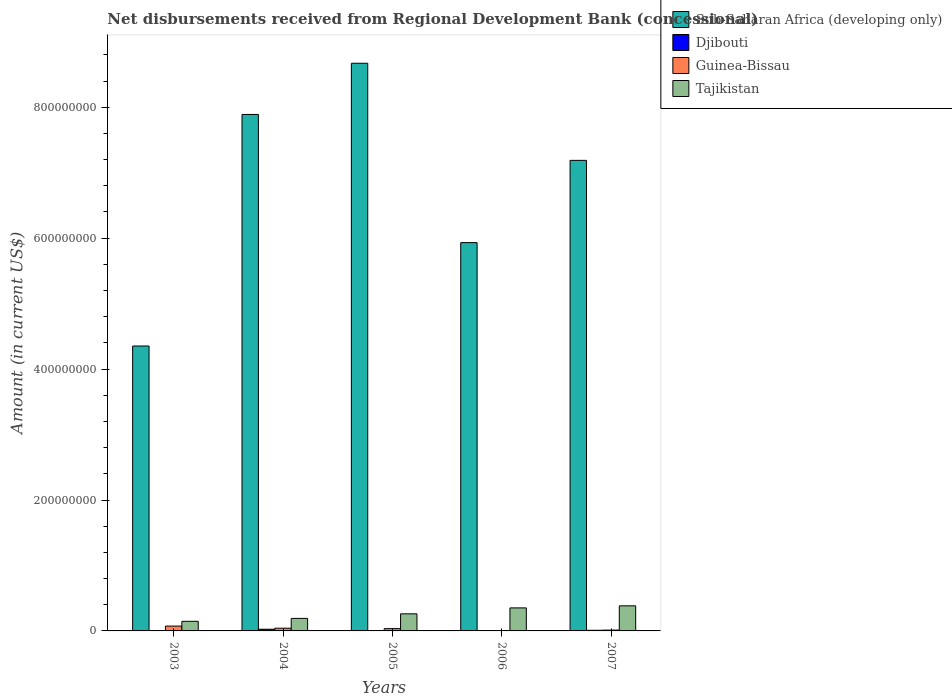How many different coloured bars are there?
Give a very brief answer. 4. Are the number of bars on each tick of the X-axis equal?
Offer a very short reply. No. How many bars are there on the 2nd tick from the left?
Provide a succinct answer. 4. How many bars are there on the 2nd tick from the right?
Ensure brevity in your answer.  4. What is the label of the 2nd group of bars from the left?
Provide a succinct answer. 2004. In how many cases, is the number of bars for a given year not equal to the number of legend labels?
Make the answer very short. 1. What is the amount of disbursements received from Regional Development Bank in Sub-Saharan Africa (developing only) in 2003?
Your answer should be compact. 4.35e+08. Across all years, what is the maximum amount of disbursements received from Regional Development Bank in Djibouti?
Your response must be concise. 2.58e+06. Across all years, what is the minimum amount of disbursements received from Regional Development Bank in Sub-Saharan Africa (developing only)?
Keep it short and to the point. 4.35e+08. In which year was the amount of disbursements received from Regional Development Bank in Guinea-Bissau maximum?
Ensure brevity in your answer.  2003. What is the total amount of disbursements received from Regional Development Bank in Sub-Saharan Africa (developing only) in the graph?
Ensure brevity in your answer.  3.40e+09. What is the difference between the amount of disbursements received from Regional Development Bank in Tajikistan in 2003 and that in 2006?
Make the answer very short. -2.05e+07. What is the difference between the amount of disbursements received from Regional Development Bank in Tajikistan in 2003 and the amount of disbursements received from Regional Development Bank in Djibouti in 2005?
Provide a succinct answer. 1.41e+07. What is the average amount of disbursements received from Regional Development Bank in Sub-Saharan Africa (developing only) per year?
Your answer should be compact. 6.81e+08. In the year 2005, what is the difference between the amount of disbursements received from Regional Development Bank in Tajikistan and amount of disbursements received from Regional Development Bank in Guinea-Bissau?
Provide a succinct answer. 2.26e+07. In how many years, is the amount of disbursements received from Regional Development Bank in Sub-Saharan Africa (developing only) greater than 600000000 US$?
Keep it short and to the point. 3. What is the ratio of the amount of disbursements received from Regional Development Bank in Tajikistan in 2003 to that in 2004?
Your response must be concise. 0.77. Is the difference between the amount of disbursements received from Regional Development Bank in Tajikistan in 2003 and 2004 greater than the difference between the amount of disbursements received from Regional Development Bank in Guinea-Bissau in 2003 and 2004?
Give a very brief answer. No. What is the difference between the highest and the second highest amount of disbursements received from Regional Development Bank in Sub-Saharan Africa (developing only)?
Give a very brief answer. 7.82e+07. What is the difference between the highest and the lowest amount of disbursements received from Regional Development Bank in Guinea-Bissau?
Your answer should be compact. 6.83e+06. In how many years, is the amount of disbursements received from Regional Development Bank in Sub-Saharan Africa (developing only) greater than the average amount of disbursements received from Regional Development Bank in Sub-Saharan Africa (developing only) taken over all years?
Ensure brevity in your answer.  3. Is it the case that in every year, the sum of the amount of disbursements received from Regional Development Bank in Tajikistan and amount of disbursements received from Regional Development Bank in Djibouti is greater than the amount of disbursements received from Regional Development Bank in Guinea-Bissau?
Offer a very short reply. Yes. Are all the bars in the graph horizontal?
Provide a succinct answer. No. What is the difference between two consecutive major ticks on the Y-axis?
Provide a short and direct response. 2.00e+08. Are the values on the major ticks of Y-axis written in scientific E-notation?
Provide a succinct answer. No. What is the title of the graph?
Provide a succinct answer. Net disbursements received from Regional Development Bank (concessional). Does "Latin America(developing only)" appear as one of the legend labels in the graph?
Make the answer very short. No. What is the label or title of the Y-axis?
Your response must be concise. Amount (in current US$). What is the Amount (in current US$) of Sub-Saharan Africa (developing only) in 2003?
Provide a succinct answer. 4.35e+08. What is the Amount (in current US$) in Guinea-Bissau in 2003?
Provide a succinct answer. 7.40e+06. What is the Amount (in current US$) of Tajikistan in 2003?
Make the answer very short. 1.47e+07. What is the Amount (in current US$) of Sub-Saharan Africa (developing only) in 2004?
Make the answer very short. 7.89e+08. What is the Amount (in current US$) of Djibouti in 2004?
Keep it short and to the point. 2.58e+06. What is the Amount (in current US$) of Guinea-Bissau in 2004?
Give a very brief answer. 4.14e+06. What is the Amount (in current US$) of Tajikistan in 2004?
Keep it short and to the point. 1.91e+07. What is the Amount (in current US$) in Sub-Saharan Africa (developing only) in 2005?
Your response must be concise. 8.67e+08. What is the Amount (in current US$) of Djibouti in 2005?
Keep it short and to the point. 5.57e+05. What is the Amount (in current US$) of Guinea-Bissau in 2005?
Your response must be concise. 3.49e+06. What is the Amount (in current US$) in Tajikistan in 2005?
Your answer should be very brief. 2.61e+07. What is the Amount (in current US$) of Sub-Saharan Africa (developing only) in 2006?
Ensure brevity in your answer.  5.93e+08. What is the Amount (in current US$) of Djibouti in 2006?
Provide a short and direct response. 3.02e+05. What is the Amount (in current US$) in Guinea-Bissau in 2006?
Your answer should be very brief. 5.69e+05. What is the Amount (in current US$) of Tajikistan in 2006?
Your answer should be very brief. 3.52e+07. What is the Amount (in current US$) in Sub-Saharan Africa (developing only) in 2007?
Your answer should be very brief. 7.19e+08. What is the Amount (in current US$) of Djibouti in 2007?
Give a very brief answer. 9.96e+05. What is the Amount (in current US$) of Guinea-Bissau in 2007?
Your answer should be compact. 1.22e+06. What is the Amount (in current US$) of Tajikistan in 2007?
Your answer should be compact. 3.83e+07. Across all years, what is the maximum Amount (in current US$) in Sub-Saharan Africa (developing only)?
Give a very brief answer. 8.67e+08. Across all years, what is the maximum Amount (in current US$) of Djibouti?
Your response must be concise. 2.58e+06. Across all years, what is the maximum Amount (in current US$) of Guinea-Bissau?
Your answer should be compact. 7.40e+06. Across all years, what is the maximum Amount (in current US$) in Tajikistan?
Your response must be concise. 3.83e+07. Across all years, what is the minimum Amount (in current US$) in Sub-Saharan Africa (developing only)?
Your answer should be compact. 4.35e+08. Across all years, what is the minimum Amount (in current US$) of Guinea-Bissau?
Keep it short and to the point. 5.69e+05. Across all years, what is the minimum Amount (in current US$) of Tajikistan?
Provide a succinct answer. 1.47e+07. What is the total Amount (in current US$) of Sub-Saharan Africa (developing only) in the graph?
Give a very brief answer. 3.40e+09. What is the total Amount (in current US$) in Djibouti in the graph?
Ensure brevity in your answer.  4.43e+06. What is the total Amount (in current US$) in Guinea-Bissau in the graph?
Offer a very short reply. 1.68e+07. What is the total Amount (in current US$) of Tajikistan in the graph?
Keep it short and to the point. 1.33e+08. What is the difference between the Amount (in current US$) in Sub-Saharan Africa (developing only) in 2003 and that in 2004?
Your response must be concise. -3.54e+08. What is the difference between the Amount (in current US$) in Guinea-Bissau in 2003 and that in 2004?
Provide a short and direct response. 3.25e+06. What is the difference between the Amount (in current US$) of Tajikistan in 2003 and that in 2004?
Offer a very short reply. -4.45e+06. What is the difference between the Amount (in current US$) in Sub-Saharan Africa (developing only) in 2003 and that in 2005?
Provide a short and direct response. -4.32e+08. What is the difference between the Amount (in current US$) of Guinea-Bissau in 2003 and that in 2005?
Offer a very short reply. 3.90e+06. What is the difference between the Amount (in current US$) in Tajikistan in 2003 and that in 2005?
Offer a terse response. -1.14e+07. What is the difference between the Amount (in current US$) in Sub-Saharan Africa (developing only) in 2003 and that in 2006?
Give a very brief answer. -1.58e+08. What is the difference between the Amount (in current US$) in Guinea-Bissau in 2003 and that in 2006?
Keep it short and to the point. 6.83e+06. What is the difference between the Amount (in current US$) in Tajikistan in 2003 and that in 2006?
Your response must be concise. -2.05e+07. What is the difference between the Amount (in current US$) in Sub-Saharan Africa (developing only) in 2003 and that in 2007?
Offer a very short reply. -2.84e+08. What is the difference between the Amount (in current US$) of Guinea-Bissau in 2003 and that in 2007?
Provide a short and direct response. 6.18e+06. What is the difference between the Amount (in current US$) in Tajikistan in 2003 and that in 2007?
Your answer should be very brief. -2.37e+07. What is the difference between the Amount (in current US$) of Sub-Saharan Africa (developing only) in 2004 and that in 2005?
Provide a succinct answer. -7.82e+07. What is the difference between the Amount (in current US$) in Djibouti in 2004 and that in 2005?
Make the answer very short. 2.02e+06. What is the difference between the Amount (in current US$) in Guinea-Bissau in 2004 and that in 2005?
Your response must be concise. 6.48e+05. What is the difference between the Amount (in current US$) of Tajikistan in 2004 and that in 2005?
Your answer should be very brief. -6.98e+06. What is the difference between the Amount (in current US$) of Sub-Saharan Africa (developing only) in 2004 and that in 2006?
Your answer should be very brief. 1.96e+08. What is the difference between the Amount (in current US$) in Djibouti in 2004 and that in 2006?
Your answer should be very brief. 2.28e+06. What is the difference between the Amount (in current US$) of Guinea-Bissau in 2004 and that in 2006?
Offer a very short reply. 3.57e+06. What is the difference between the Amount (in current US$) of Tajikistan in 2004 and that in 2006?
Provide a succinct answer. -1.60e+07. What is the difference between the Amount (in current US$) in Sub-Saharan Africa (developing only) in 2004 and that in 2007?
Offer a very short reply. 7.01e+07. What is the difference between the Amount (in current US$) in Djibouti in 2004 and that in 2007?
Offer a very short reply. 1.58e+06. What is the difference between the Amount (in current US$) in Guinea-Bissau in 2004 and that in 2007?
Your response must be concise. 2.92e+06. What is the difference between the Amount (in current US$) of Tajikistan in 2004 and that in 2007?
Make the answer very short. -1.92e+07. What is the difference between the Amount (in current US$) of Sub-Saharan Africa (developing only) in 2005 and that in 2006?
Your answer should be compact. 2.74e+08. What is the difference between the Amount (in current US$) in Djibouti in 2005 and that in 2006?
Give a very brief answer. 2.55e+05. What is the difference between the Amount (in current US$) in Guinea-Bissau in 2005 and that in 2006?
Your answer should be compact. 2.92e+06. What is the difference between the Amount (in current US$) of Tajikistan in 2005 and that in 2006?
Ensure brevity in your answer.  -9.06e+06. What is the difference between the Amount (in current US$) in Sub-Saharan Africa (developing only) in 2005 and that in 2007?
Keep it short and to the point. 1.48e+08. What is the difference between the Amount (in current US$) of Djibouti in 2005 and that in 2007?
Offer a terse response. -4.39e+05. What is the difference between the Amount (in current US$) in Guinea-Bissau in 2005 and that in 2007?
Make the answer very short. 2.27e+06. What is the difference between the Amount (in current US$) in Tajikistan in 2005 and that in 2007?
Provide a short and direct response. -1.22e+07. What is the difference between the Amount (in current US$) of Sub-Saharan Africa (developing only) in 2006 and that in 2007?
Provide a short and direct response. -1.26e+08. What is the difference between the Amount (in current US$) of Djibouti in 2006 and that in 2007?
Offer a very short reply. -6.94e+05. What is the difference between the Amount (in current US$) in Guinea-Bissau in 2006 and that in 2007?
Offer a terse response. -6.51e+05. What is the difference between the Amount (in current US$) in Tajikistan in 2006 and that in 2007?
Provide a succinct answer. -3.17e+06. What is the difference between the Amount (in current US$) in Sub-Saharan Africa (developing only) in 2003 and the Amount (in current US$) in Djibouti in 2004?
Provide a succinct answer. 4.33e+08. What is the difference between the Amount (in current US$) in Sub-Saharan Africa (developing only) in 2003 and the Amount (in current US$) in Guinea-Bissau in 2004?
Give a very brief answer. 4.31e+08. What is the difference between the Amount (in current US$) in Sub-Saharan Africa (developing only) in 2003 and the Amount (in current US$) in Tajikistan in 2004?
Offer a very short reply. 4.16e+08. What is the difference between the Amount (in current US$) in Guinea-Bissau in 2003 and the Amount (in current US$) in Tajikistan in 2004?
Ensure brevity in your answer.  -1.17e+07. What is the difference between the Amount (in current US$) of Sub-Saharan Africa (developing only) in 2003 and the Amount (in current US$) of Djibouti in 2005?
Your answer should be very brief. 4.35e+08. What is the difference between the Amount (in current US$) of Sub-Saharan Africa (developing only) in 2003 and the Amount (in current US$) of Guinea-Bissau in 2005?
Make the answer very short. 4.32e+08. What is the difference between the Amount (in current US$) in Sub-Saharan Africa (developing only) in 2003 and the Amount (in current US$) in Tajikistan in 2005?
Provide a succinct answer. 4.09e+08. What is the difference between the Amount (in current US$) in Guinea-Bissau in 2003 and the Amount (in current US$) in Tajikistan in 2005?
Make the answer very short. -1.87e+07. What is the difference between the Amount (in current US$) of Sub-Saharan Africa (developing only) in 2003 and the Amount (in current US$) of Djibouti in 2006?
Provide a short and direct response. 4.35e+08. What is the difference between the Amount (in current US$) of Sub-Saharan Africa (developing only) in 2003 and the Amount (in current US$) of Guinea-Bissau in 2006?
Give a very brief answer. 4.35e+08. What is the difference between the Amount (in current US$) of Sub-Saharan Africa (developing only) in 2003 and the Amount (in current US$) of Tajikistan in 2006?
Your answer should be very brief. 4.00e+08. What is the difference between the Amount (in current US$) of Guinea-Bissau in 2003 and the Amount (in current US$) of Tajikistan in 2006?
Provide a short and direct response. -2.78e+07. What is the difference between the Amount (in current US$) in Sub-Saharan Africa (developing only) in 2003 and the Amount (in current US$) in Djibouti in 2007?
Keep it short and to the point. 4.34e+08. What is the difference between the Amount (in current US$) in Sub-Saharan Africa (developing only) in 2003 and the Amount (in current US$) in Guinea-Bissau in 2007?
Ensure brevity in your answer.  4.34e+08. What is the difference between the Amount (in current US$) of Sub-Saharan Africa (developing only) in 2003 and the Amount (in current US$) of Tajikistan in 2007?
Provide a short and direct response. 3.97e+08. What is the difference between the Amount (in current US$) of Guinea-Bissau in 2003 and the Amount (in current US$) of Tajikistan in 2007?
Ensure brevity in your answer.  -3.09e+07. What is the difference between the Amount (in current US$) of Sub-Saharan Africa (developing only) in 2004 and the Amount (in current US$) of Djibouti in 2005?
Provide a succinct answer. 7.88e+08. What is the difference between the Amount (in current US$) in Sub-Saharan Africa (developing only) in 2004 and the Amount (in current US$) in Guinea-Bissau in 2005?
Keep it short and to the point. 7.86e+08. What is the difference between the Amount (in current US$) of Sub-Saharan Africa (developing only) in 2004 and the Amount (in current US$) of Tajikistan in 2005?
Your response must be concise. 7.63e+08. What is the difference between the Amount (in current US$) in Djibouti in 2004 and the Amount (in current US$) in Guinea-Bissau in 2005?
Offer a terse response. -9.15e+05. What is the difference between the Amount (in current US$) in Djibouti in 2004 and the Amount (in current US$) in Tajikistan in 2005?
Keep it short and to the point. -2.35e+07. What is the difference between the Amount (in current US$) in Guinea-Bissau in 2004 and the Amount (in current US$) in Tajikistan in 2005?
Give a very brief answer. -2.20e+07. What is the difference between the Amount (in current US$) in Sub-Saharan Africa (developing only) in 2004 and the Amount (in current US$) in Djibouti in 2006?
Provide a short and direct response. 7.89e+08. What is the difference between the Amount (in current US$) of Sub-Saharan Africa (developing only) in 2004 and the Amount (in current US$) of Guinea-Bissau in 2006?
Make the answer very short. 7.88e+08. What is the difference between the Amount (in current US$) in Sub-Saharan Africa (developing only) in 2004 and the Amount (in current US$) in Tajikistan in 2006?
Offer a very short reply. 7.54e+08. What is the difference between the Amount (in current US$) of Djibouti in 2004 and the Amount (in current US$) of Guinea-Bissau in 2006?
Ensure brevity in your answer.  2.01e+06. What is the difference between the Amount (in current US$) of Djibouti in 2004 and the Amount (in current US$) of Tajikistan in 2006?
Ensure brevity in your answer.  -3.26e+07. What is the difference between the Amount (in current US$) in Guinea-Bissau in 2004 and the Amount (in current US$) in Tajikistan in 2006?
Provide a short and direct response. -3.10e+07. What is the difference between the Amount (in current US$) in Sub-Saharan Africa (developing only) in 2004 and the Amount (in current US$) in Djibouti in 2007?
Provide a short and direct response. 7.88e+08. What is the difference between the Amount (in current US$) of Sub-Saharan Africa (developing only) in 2004 and the Amount (in current US$) of Guinea-Bissau in 2007?
Keep it short and to the point. 7.88e+08. What is the difference between the Amount (in current US$) in Sub-Saharan Africa (developing only) in 2004 and the Amount (in current US$) in Tajikistan in 2007?
Make the answer very short. 7.51e+08. What is the difference between the Amount (in current US$) of Djibouti in 2004 and the Amount (in current US$) of Guinea-Bissau in 2007?
Give a very brief answer. 1.36e+06. What is the difference between the Amount (in current US$) in Djibouti in 2004 and the Amount (in current US$) in Tajikistan in 2007?
Your answer should be compact. -3.58e+07. What is the difference between the Amount (in current US$) in Guinea-Bissau in 2004 and the Amount (in current US$) in Tajikistan in 2007?
Keep it short and to the point. -3.42e+07. What is the difference between the Amount (in current US$) of Sub-Saharan Africa (developing only) in 2005 and the Amount (in current US$) of Djibouti in 2006?
Provide a short and direct response. 8.67e+08. What is the difference between the Amount (in current US$) in Sub-Saharan Africa (developing only) in 2005 and the Amount (in current US$) in Guinea-Bissau in 2006?
Ensure brevity in your answer.  8.67e+08. What is the difference between the Amount (in current US$) in Sub-Saharan Africa (developing only) in 2005 and the Amount (in current US$) in Tajikistan in 2006?
Make the answer very short. 8.32e+08. What is the difference between the Amount (in current US$) of Djibouti in 2005 and the Amount (in current US$) of Guinea-Bissau in 2006?
Your answer should be compact. -1.20e+04. What is the difference between the Amount (in current US$) in Djibouti in 2005 and the Amount (in current US$) in Tajikistan in 2006?
Your answer should be very brief. -3.46e+07. What is the difference between the Amount (in current US$) of Guinea-Bissau in 2005 and the Amount (in current US$) of Tajikistan in 2006?
Offer a very short reply. -3.17e+07. What is the difference between the Amount (in current US$) of Sub-Saharan Africa (developing only) in 2005 and the Amount (in current US$) of Djibouti in 2007?
Your answer should be compact. 8.66e+08. What is the difference between the Amount (in current US$) in Sub-Saharan Africa (developing only) in 2005 and the Amount (in current US$) in Guinea-Bissau in 2007?
Offer a terse response. 8.66e+08. What is the difference between the Amount (in current US$) of Sub-Saharan Africa (developing only) in 2005 and the Amount (in current US$) of Tajikistan in 2007?
Your answer should be very brief. 8.29e+08. What is the difference between the Amount (in current US$) of Djibouti in 2005 and the Amount (in current US$) of Guinea-Bissau in 2007?
Offer a terse response. -6.63e+05. What is the difference between the Amount (in current US$) of Djibouti in 2005 and the Amount (in current US$) of Tajikistan in 2007?
Keep it short and to the point. -3.78e+07. What is the difference between the Amount (in current US$) of Guinea-Bissau in 2005 and the Amount (in current US$) of Tajikistan in 2007?
Offer a terse response. -3.48e+07. What is the difference between the Amount (in current US$) of Sub-Saharan Africa (developing only) in 2006 and the Amount (in current US$) of Djibouti in 2007?
Give a very brief answer. 5.92e+08. What is the difference between the Amount (in current US$) in Sub-Saharan Africa (developing only) in 2006 and the Amount (in current US$) in Guinea-Bissau in 2007?
Provide a succinct answer. 5.92e+08. What is the difference between the Amount (in current US$) of Sub-Saharan Africa (developing only) in 2006 and the Amount (in current US$) of Tajikistan in 2007?
Offer a very short reply. 5.55e+08. What is the difference between the Amount (in current US$) of Djibouti in 2006 and the Amount (in current US$) of Guinea-Bissau in 2007?
Make the answer very short. -9.18e+05. What is the difference between the Amount (in current US$) in Djibouti in 2006 and the Amount (in current US$) in Tajikistan in 2007?
Your answer should be compact. -3.80e+07. What is the difference between the Amount (in current US$) of Guinea-Bissau in 2006 and the Amount (in current US$) of Tajikistan in 2007?
Make the answer very short. -3.78e+07. What is the average Amount (in current US$) of Sub-Saharan Africa (developing only) per year?
Your answer should be compact. 6.81e+08. What is the average Amount (in current US$) in Djibouti per year?
Your response must be concise. 8.87e+05. What is the average Amount (in current US$) in Guinea-Bissau per year?
Offer a terse response. 3.36e+06. What is the average Amount (in current US$) in Tajikistan per year?
Offer a terse response. 2.67e+07. In the year 2003, what is the difference between the Amount (in current US$) in Sub-Saharan Africa (developing only) and Amount (in current US$) in Guinea-Bissau?
Keep it short and to the point. 4.28e+08. In the year 2003, what is the difference between the Amount (in current US$) in Sub-Saharan Africa (developing only) and Amount (in current US$) in Tajikistan?
Your response must be concise. 4.21e+08. In the year 2003, what is the difference between the Amount (in current US$) of Guinea-Bissau and Amount (in current US$) of Tajikistan?
Provide a succinct answer. -7.28e+06. In the year 2004, what is the difference between the Amount (in current US$) of Sub-Saharan Africa (developing only) and Amount (in current US$) of Djibouti?
Provide a short and direct response. 7.86e+08. In the year 2004, what is the difference between the Amount (in current US$) in Sub-Saharan Africa (developing only) and Amount (in current US$) in Guinea-Bissau?
Your answer should be very brief. 7.85e+08. In the year 2004, what is the difference between the Amount (in current US$) of Sub-Saharan Africa (developing only) and Amount (in current US$) of Tajikistan?
Your answer should be compact. 7.70e+08. In the year 2004, what is the difference between the Amount (in current US$) of Djibouti and Amount (in current US$) of Guinea-Bissau?
Make the answer very short. -1.56e+06. In the year 2004, what is the difference between the Amount (in current US$) of Djibouti and Amount (in current US$) of Tajikistan?
Offer a very short reply. -1.66e+07. In the year 2004, what is the difference between the Amount (in current US$) in Guinea-Bissau and Amount (in current US$) in Tajikistan?
Your response must be concise. -1.50e+07. In the year 2005, what is the difference between the Amount (in current US$) in Sub-Saharan Africa (developing only) and Amount (in current US$) in Djibouti?
Make the answer very short. 8.67e+08. In the year 2005, what is the difference between the Amount (in current US$) in Sub-Saharan Africa (developing only) and Amount (in current US$) in Guinea-Bissau?
Your answer should be compact. 8.64e+08. In the year 2005, what is the difference between the Amount (in current US$) of Sub-Saharan Africa (developing only) and Amount (in current US$) of Tajikistan?
Provide a succinct answer. 8.41e+08. In the year 2005, what is the difference between the Amount (in current US$) in Djibouti and Amount (in current US$) in Guinea-Bissau?
Make the answer very short. -2.94e+06. In the year 2005, what is the difference between the Amount (in current US$) in Djibouti and Amount (in current US$) in Tajikistan?
Your answer should be compact. -2.56e+07. In the year 2005, what is the difference between the Amount (in current US$) in Guinea-Bissau and Amount (in current US$) in Tajikistan?
Offer a very short reply. -2.26e+07. In the year 2006, what is the difference between the Amount (in current US$) in Sub-Saharan Africa (developing only) and Amount (in current US$) in Djibouti?
Your response must be concise. 5.93e+08. In the year 2006, what is the difference between the Amount (in current US$) of Sub-Saharan Africa (developing only) and Amount (in current US$) of Guinea-Bissau?
Offer a terse response. 5.93e+08. In the year 2006, what is the difference between the Amount (in current US$) in Sub-Saharan Africa (developing only) and Amount (in current US$) in Tajikistan?
Offer a very short reply. 5.58e+08. In the year 2006, what is the difference between the Amount (in current US$) in Djibouti and Amount (in current US$) in Guinea-Bissau?
Your response must be concise. -2.67e+05. In the year 2006, what is the difference between the Amount (in current US$) of Djibouti and Amount (in current US$) of Tajikistan?
Provide a succinct answer. -3.49e+07. In the year 2006, what is the difference between the Amount (in current US$) in Guinea-Bissau and Amount (in current US$) in Tajikistan?
Keep it short and to the point. -3.46e+07. In the year 2007, what is the difference between the Amount (in current US$) in Sub-Saharan Africa (developing only) and Amount (in current US$) in Djibouti?
Your answer should be compact. 7.18e+08. In the year 2007, what is the difference between the Amount (in current US$) in Sub-Saharan Africa (developing only) and Amount (in current US$) in Guinea-Bissau?
Make the answer very short. 7.18e+08. In the year 2007, what is the difference between the Amount (in current US$) of Sub-Saharan Africa (developing only) and Amount (in current US$) of Tajikistan?
Your answer should be compact. 6.81e+08. In the year 2007, what is the difference between the Amount (in current US$) of Djibouti and Amount (in current US$) of Guinea-Bissau?
Your answer should be compact. -2.24e+05. In the year 2007, what is the difference between the Amount (in current US$) in Djibouti and Amount (in current US$) in Tajikistan?
Offer a terse response. -3.73e+07. In the year 2007, what is the difference between the Amount (in current US$) of Guinea-Bissau and Amount (in current US$) of Tajikistan?
Your answer should be compact. -3.71e+07. What is the ratio of the Amount (in current US$) in Sub-Saharan Africa (developing only) in 2003 to that in 2004?
Offer a very short reply. 0.55. What is the ratio of the Amount (in current US$) in Guinea-Bissau in 2003 to that in 2004?
Provide a succinct answer. 1.79. What is the ratio of the Amount (in current US$) in Tajikistan in 2003 to that in 2004?
Give a very brief answer. 0.77. What is the ratio of the Amount (in current US$) of Sub-Saharan Africa (developing only) in 2003 to that in 2005?
Offer a terse response. 0.5. What is the ratio of the Amount (in current US$) in Guinea-Bissau in 2003 to that in 2005?
Provide a short and direct response. 2.12. What is the ratio of the Amount (in current US$) in Tajikistan in 2003 to that in 2005?
Give a very brief answer. 0.56. What is the ratio of the Amount (in current US$) of Sub-Saharan Africa (developing only) in 2003 to that in 2006?
Provide a short and direct response. 0.73. What is the ratio of the Amount (in current US$) of Guinea-Bissau in 2003 to that in 2006?
Provide a short and direct response. 13. What is the ratio of the Amount (in current US$) of Tajikistan in 2003 to that in 2006?
Keep it short and to the point. 0.42. What is the ratio of the Amount (in current US$) in Sub-Saharan Africa (developing only) in 2003 to that in 2007?
Give a very brief answer. 0.61. What is the ratio of the Amount (in current US$) in Guinea-Bissau in 2003 to that in 2007?
Give a very brief answer. 6.06. What is the ratio of the Amount (in current US$) of Tajikistan in 2003 to that in 2007?
Keep it short and to the point. 0.38. What is the ratio of the Amount (in current US$) of Sub-Saharan Africa (developing only) in 2004 to that in 2005?
Keep it short and to the point. 0.91. What is the ratio of the Amount (in current US$) in Djibouti in 2004 to that in 2005?
Give a very brief answer. 4.63. What is the ratio of the Amount (in current US$) in Guinea-Bissau in 2004 to that in 2005?
Make the answer very short. 1.19. What is the ratio of the Amount (in current US$) in Tajikistan in 2004 to that in 2005?
Your answer should be compact. 0.73. What is the ratio of the Amount (in current US$) in Sub-Saharan Africa (developing only) in 2004 to that in 2006?
Your response must be concise. 1.33. What is the ratio of the Amount (in current US$) of Djibouti in 2004 to that in 2006?
Provide a succinct answer. 8.54. What is the ratio of the Amount (in current US$) in Guinea-Bissau in 2004 to that in 2006?
Your answer should be very brief. 7.28. What is the ratio of the Amount (in current US$) of Tajikistan in 2004 to that in 2006?
Provide a succinct answer. 0.54. What is the ratio of the Amount (in current US$) of Sub-Saharan Africa (developing only) in 2004 to that in 2007?
Your answer should be compact. 1.1. What is the ratio of the Amount (in current US$) of Djibouti in 2004 to that in 2007?
Provide a short and direct response. 2.59. What is the ratio of the Amount (in current US$) of Guinea-Bissau in 2004 to that in 2007?
Give a very brief answer. 3.39. What is the ratio of the Amount (in current US$) in Tajikistan in 2004 to that in 2007?
Give a very brief answer. 0.5. What is the ratio of the Amount (in current US$) of Sub-Saharan Africa (developing only) in 2005 to that in 2006?
Ensure brevity in your answer.  1.46. What is the ratio of the Amount (in current US$) in Djibouti in 2005 to that in 2006?
Your answer should be very brief. 1.84. What is the ratio of the Amount (in current US$) of Guinea-Bissau in 2005 to that in 2006?
Give a very brief answer. 6.14. What is the ratio of the Amount (in current US$) in Tajikistan in 2005 to that in 2006?
Provide a short and direct response. 0.74. What is the ratio of the Amount (in current US$) in Sub-Saharan Africa (developing only) in 2005 to that in 2007?
Make the answer very short. 1.21. What is the ratio of the Amount (in current US$) in Djibouti in 2005 to that in 2007?
Offer a terse response. 0.56. What is the ratio of the Amount (in current US$) of Guinea-Bissau in 2005 to that in 2007?
Ensure brevity in your answer.  2.86. What is the ratio of the Amount (in current US$) of Tajikistan in 2005 to that in 2007?
Offer a terse response. 0.68. What is the ratio of the Amount (in current US$) in Sub-Saharan Africa (developing only) in 2006 to that in 2007?
Provide a succinct answer. 0.83. What is the ratio of the Amount (in current US$) in Djibouti in 2006 to that in 2007?
Your response must be concise. 0.3. What is the ratio of the Amount (in current US$) of Guinea-Bissau in 2006 to that in 2007?
Make the answer very short. 0.47. What is the ratio of the Amount (in current US$) of Tajikistan in 2006 to that in 2007?
Offer a terse response. 0.92. What is the difference between the highest and the second highest Amount (in current US$) in Sub-Saharan Africa (developing only)?
Provide a succinct answer. 7.82e+07. What is the difference between the highest and the second highest Amount (in current US$) of Djibouti?
Give a very brief answer. 1.58e+06. What is the difference between the highest and the second highest Amount (in current US$) of Guinea-Bissau?
Make the answer very short. 3.25e+06. What is the difference between the highest and the second highest Amount (in current US$) in Tajikistan?
Your answer should be very brief. 3.17e+06. What is the difference between the highest and the lowest Amount (in current US$) of Sub-Saharan Africa (developing only)?
Offer a very short reply. 4.32e+08. What is the difference between the highest and the lowest Amount (in current US$) of Djibouti?
Keep it short and to the point. 2.58e+06. What is the difference between the highest and the lowest Amount (in current US$) of Guinea-Bissau?
Your answer should be compact. 6.83e+06. What is the difference between the highest and the lowest Amount (in current US$) in Tajikistan?
Provide a succinct answer. 2.37e+07. 